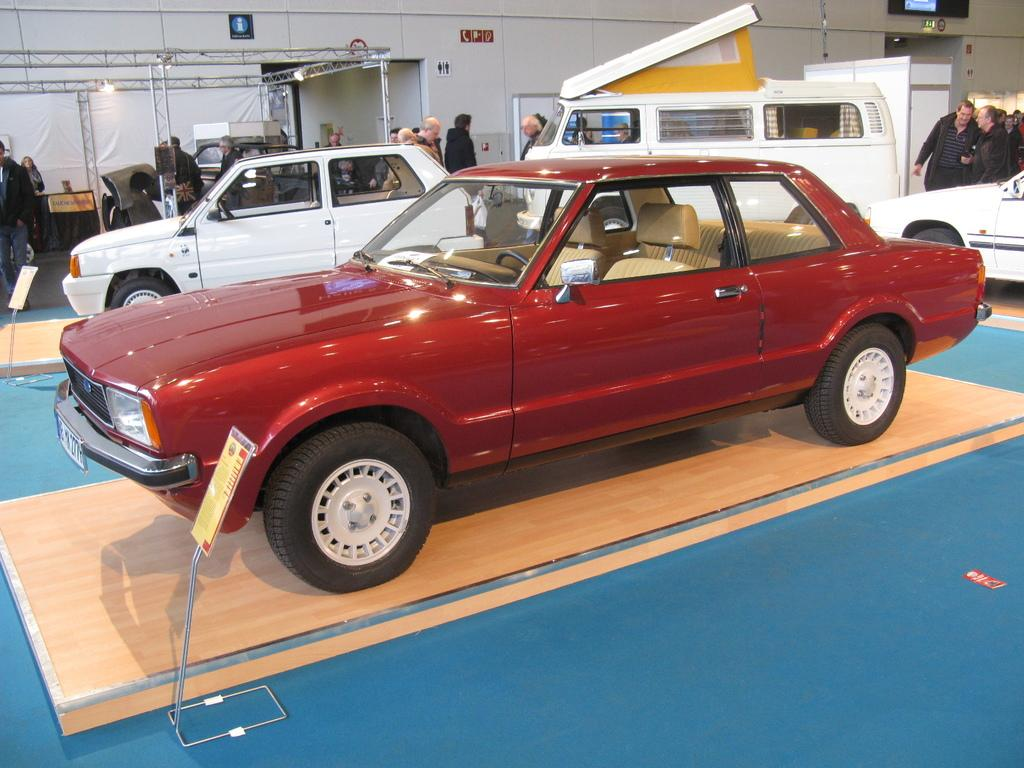What types of objects are present in the image? There are vehicles and people in the image. Can you describe the setting or environment in the image? There is a white wall in the background of the image. How many rabbits can be seen in the image? There are no rabbits present in the image. What type of paper is being used by the people in the image? There is no paper visible in the image. 